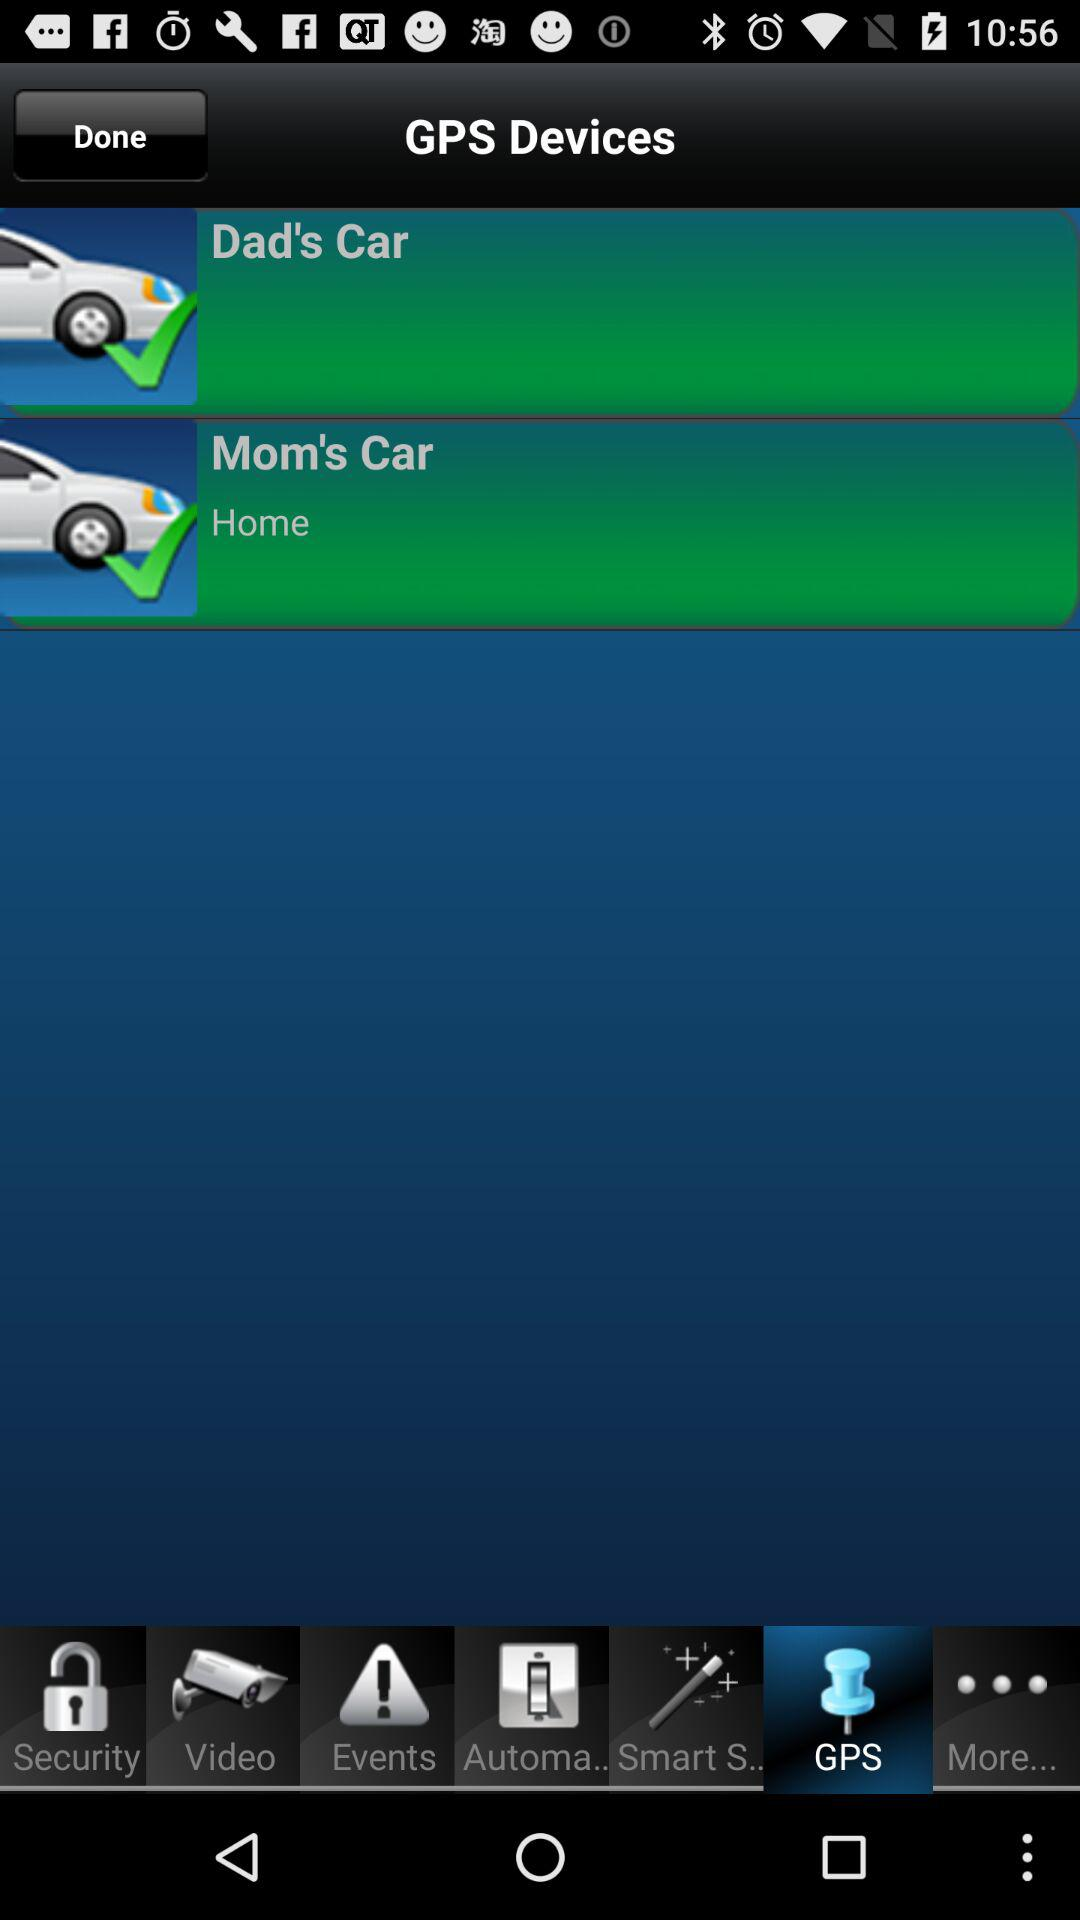Which tab is selected? The selected tab is GPS. 